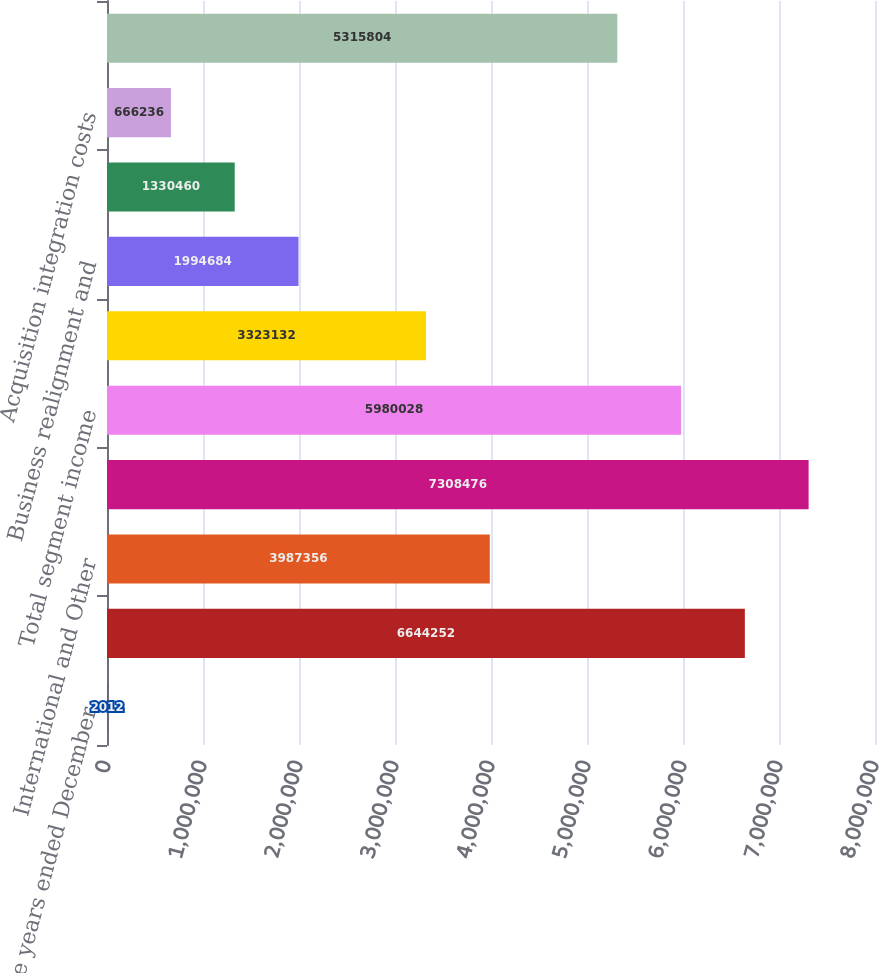Convert chart. <chart><loc_0><loc_0><loc_500><loc_500><bar_chart><fcel>For the years ended December<fcel>North America<fcel>International and Other<fcel>Total<fcel>Total segment income<fcel>Unallocated corporate expense<fcel>Business realignment and<fcel>Non-service related pension<fcel>Acquisition integration costs<fcel>Income before interest and<nl><fcel>2012<fcel>6.64425e+06<fcel>3.98736e+06<fcel>7.30848e+06<fcel>5.98003e+06<fcel>3.32313e+06<fcel>1.99468e+06<fcel>1.33046e+06<fcel>666236<fcel>5.3158e+06<nl></chart> 